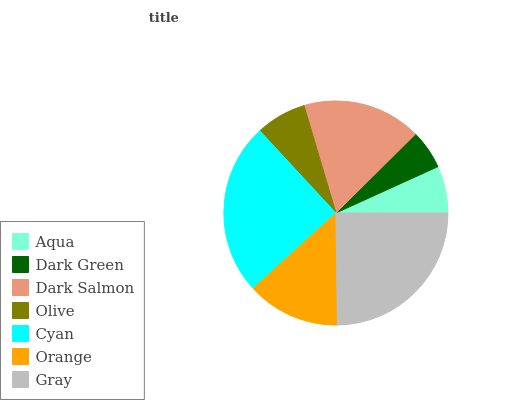Is Dark Green the minimum?
Answer yes or no. Yes. Is Cyan the maximum?
Answer yes or no. Yes. Is Dark Salmon the minimum?
Answer yes or no. No. Is Dark Salmon the maximum?
Answer yes or no. No. Is Dark Salmon greater than Dark Green?
Answer yes or no. Yes. Is Dark Green less than Dark Salmon?
Answer yes or no. Yes. Is Dark Green greater than Dark Salmon?
Answer yes or no. No. Is Dark Salmon less than Dark Green?
Answer yes or no. No. Is Orange the high median?
Answer yes or no. Yes. Is Orange the low median?
Answer yes or no. Yes. Is Olive the high median?
Answer yes or no. No. Is Cyan the low median?
Answer yes or no. No. 